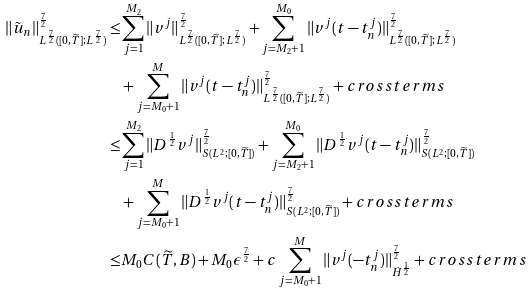Convert formula to latex. <formula><loc_0><loc_0><loc_500><loc_500>\| \tilde { u } _ { n } \| ^ { \frac { 7 } { 2 } } _ { L ^ { \frac { 7 } { 2 } } ( [ 0 , \widetilde { T } ] ; L ^ { \frac { 7 } { 2 } } ) } \leq & \sum _ { j = 1 } ^ { M _ { 2 } } \| v ^ { j } \| ^ { \frac { 7 } { 2 } } _ { L ^ { \frac { 7 } { 2 } } ( [ 0 , \widetilde { T } ] ; L ^ { \frac { 7 } { 2 } } ) } + \sum _ { j = M _ { 2 } + 1 } ^ { M _ { 0 } } \| v ^ { j } ( t - t _ { n } ^ { j } ) \| ^ { \frac { 7 } { 2 } } _ { L ^ { \frac { 7 } { 2 } } ( [ 0 , \widetilde { T } ] ; L ^ { \frac { 7 } { 2 } } ) } \\ & + \sum _ { j = M _ { 0 } + 1 } ^ { M } \| v ^ { j } ( t - t _ { n } ^ { j } ) \| ^ { \frac { 7 } { 2 } } _ { L ^ { \frac { 7 } { 2 } } ( [ 0 , \widetilde { T } ] ; L ^ { \frac { 7 } { 2 } } ) } + c r o s s t e r m s \\ \leq & \sum _ { j = 1 } ^ { M _ { 2 } } \| D ^ { \frac { 1 } { 2 } } v ^ { j } \| ^ { \frac { 7 } { 2 } } _ { S ( L ^ { 2 } ; [ 0 , \widetilde { T } ] ) } + \sum _ { j = M _ { 2 } + 1 } ^ { M _ { 0 } } \| D ^ { \frac { 1 } { 2 } } v ^ { j } ( t - t _ { n } ^ { j } ) \| ^ { \frac { 7 } { 2 } } _ { S ( L ^ { 2 } ; [ 0 , \widetilde { T } ] ) } \\ & + \sum _ { j = M _ { 0 } + 1 } ^ { M } \| D ^ { \frac { 1 } { 2 } } v ^ { j } ( t - t _ { n } ^ { j } ) \| ^ { \frac { 7 } { 2 } } _ { S ( L ^ { 2 } ; [ 0 , \widetilde { T } ] ) } + c r o s s t e r m s \\ \leq & M _ { 0 } C ( \widetilde { T } , B ) + M _ { 0 } \epsilon ^ { \frac { 7 } { 2 } } + c \sum _ { j = M _ { 0 } + 1 } ^ { M } \| v ^ { j } ( - t _ { n } ^ { j } ) \| ^ { \frac { 7 } { 2 } } _ { \dot { H } ^ { \frac { 1 } { 2 } } } + c r o s s t e r m s</formula> 